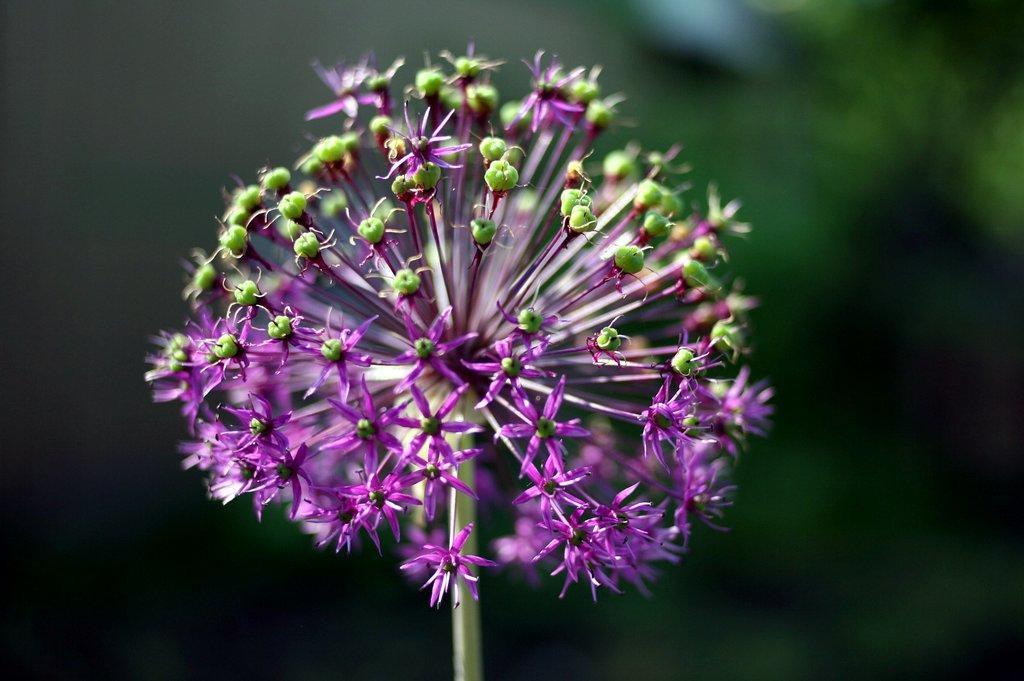Could you give a brief overview of what you see in this image? This image is taken outdoors. In this image the background is a little blurred. In the middle of the image there is a bunch of flowers on the plant. 